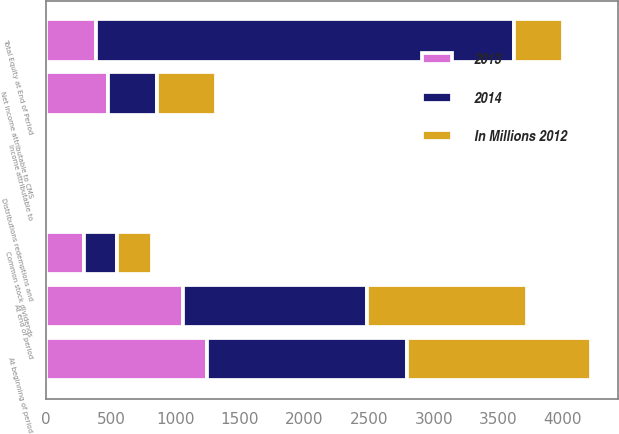Convert chart to OTSL. <chart><loc_0><loc_0><loc_500><loc_500><stacked_bar_chart><ecel><fcel>At beginning of period<fcel>Net income attributable to CMS<fcel>Common stock dividends<fcel>At end of period<fcel>Income attributable to<fcel>Distributions redemptions and<fcel>Total Equity at End of Period<nl><fcel>2013<fcel>1242<fcel>477<fcel>293<fcel>1058<fcel>2<fcel>2<fcel>382<nl><fcel>In Millions 2012<fcel>1423<fcel>452<fcel>271<fcel>1242<fcel>2<fcel>9<fcel>382<nl><fcel>2014<fcel>1553<fcel>382<fcel>252<fcel>1423<fcel>2<fcel>2<fcel>3238<nl></chart> 